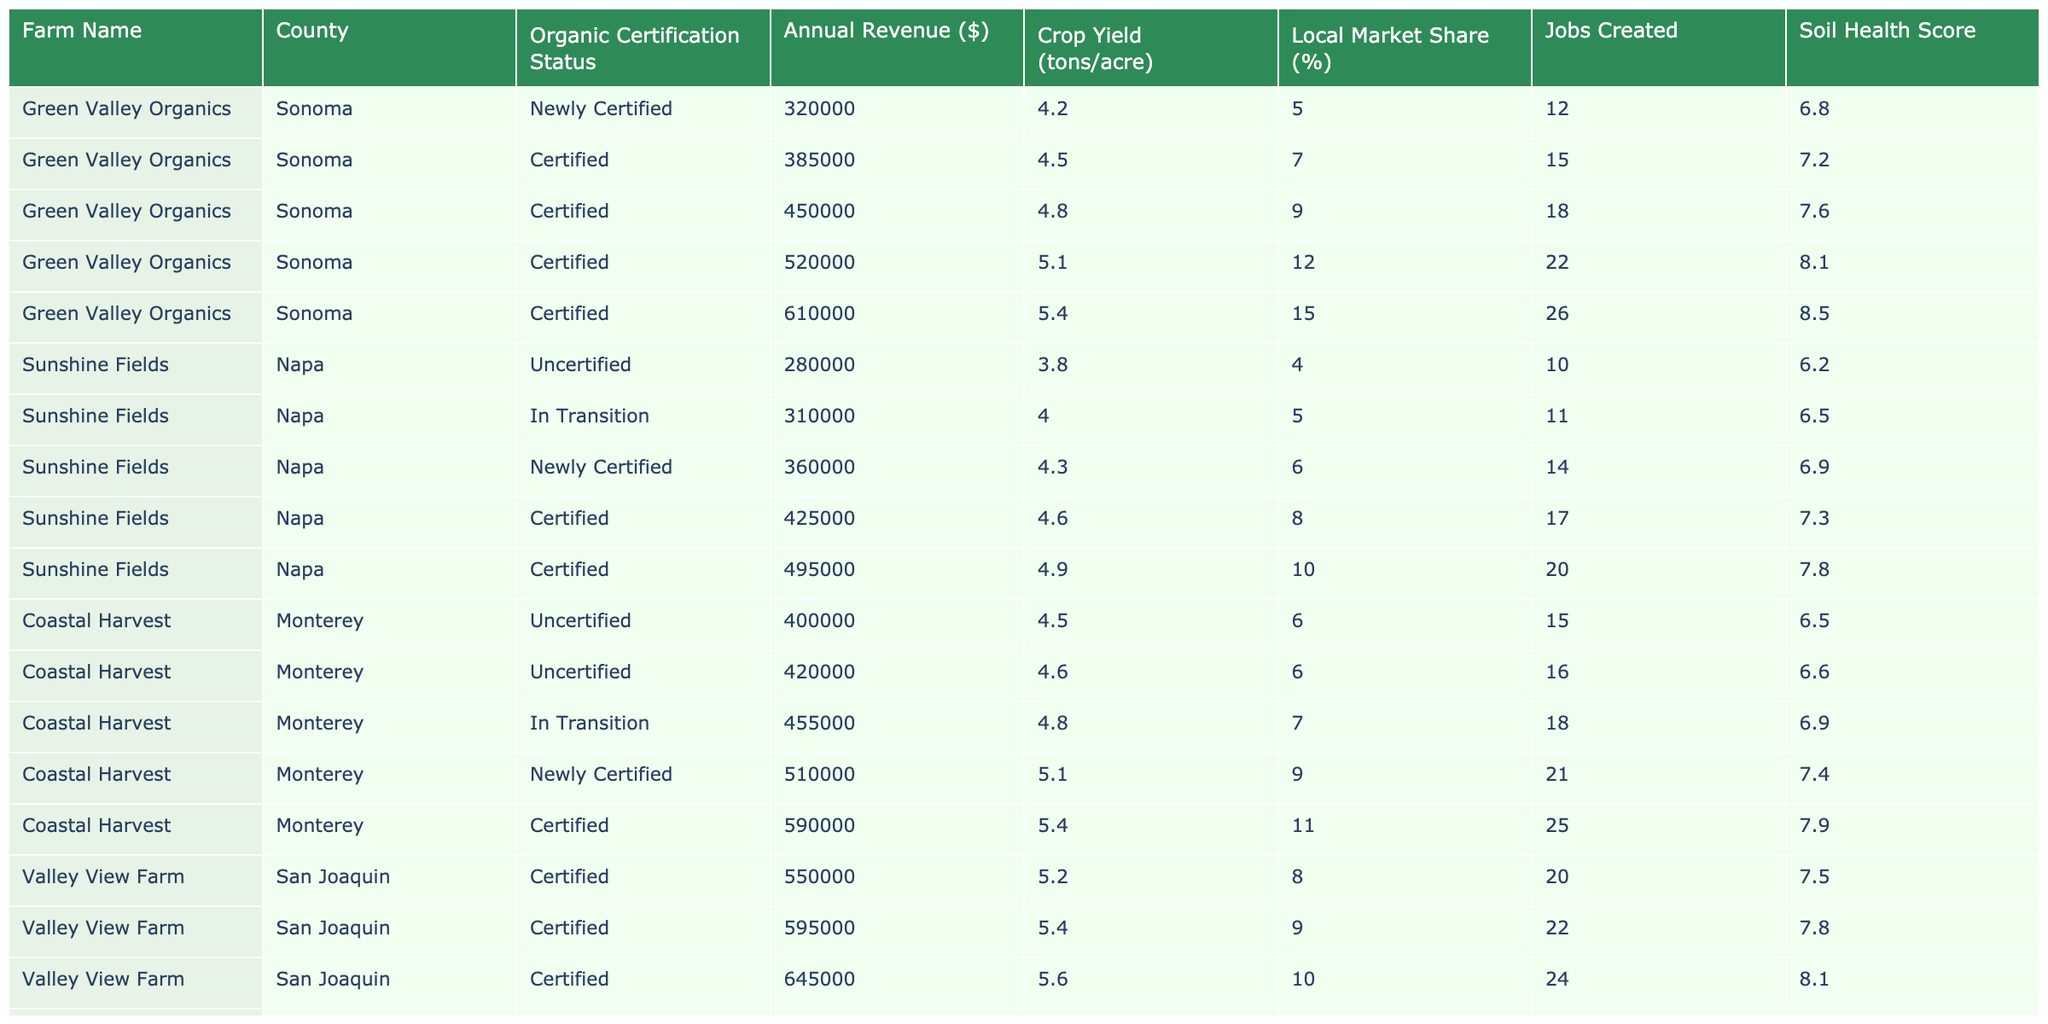What was the annual revenue of Green Valley Organics in 2022? Referring to the table, the annual revenue of Green Valley Organics in the year 2022 is specifically indicated as $610,000.
Answer: $610,000 How many jobs did Valley View Farm create in 2021? The table shows that Valley View Farm created 27 jobs in the year 2021.
Answer: 27 What is the percentage increase in annual revenue for Sunshine Fields from 2018 to 2022? The annual revenue for Sunshine Fields in 2018 was $280,000 and in 2022 it was $495,000. The increase is $495,000 - $280,000 = $215,000. To find the percentage increase, divide the increase by the original value and multiply by 100: ($215,000 / $280,000) * 100 = 76.79%.
Answer: 76.79% Did Coastal Harvest have a higher soil health score in 2022 compared to its score in 2018? In 2018, Coastal Harvest had a soil health score of 6.5, and in 2022 it had a score of 7.9. Since 7.9 is greater than 6.5, the statement is true.
Answer: Yes What was the average crop yield for Green Valley Organics over the 5-year period? The crop yields from 2018 to 2022 for Green Valley Organics are 4.2, 4.5, 4.8, 5.1, and 5.4 tons/acre. Adding these gives a sum of 24.0. Dividing by 5 yields an average crop yield of 24.0 / 5 = 4.8 tons/acre.
Answer: 4.8 tons/acre Which farm created the most jobs in 2022, and how many jobs did it create? Referring to the table, Green Valley Organics created 26 jobs in 2022, while Sunshine Fields created 20 and Coastal Harvest created 25 jobs. Thus, Green Valley Organics created the most jobs at 26.
Answer: Green Valley Organics, 26 jobs What was the local market share percentage increase for Valley View Farm from 2018 to 2022? Valley View Farm's local market share percentage in 2018 was 8%, and in 2022 it was 14%. The increase is 14% - 8% = 6%.
Answer: 6% Was the annual revenue of Coastal Harvest higher in 2021 than in 2020? The table indicates that Coastal Harvest had an annual revenue of $510,000 in 2021 compared to $455,000 in 2020. Since $510,000 is more than $455,000, the statement is true.
Answer: Yes What is the soil health score difference between the newly certified status in 2020 and the certified status in 2022 for Sunshine Fields? Sunshine Fields had a soil health score of 6.9 when newly certified in 2020 and a score of 7.8 when certified in 2022. The difference is 7.8 - 6.9 = 0.9.
Answer: 0.9 Which farm had the highest annual revenue in 2021, and what was that revenue? In 2021, Valley View Farm had the highest annual revenue of $700,000 compared to Green Valley Organics' $520,000, Sunshine Fields' $425,000, and Coastal Harvest's $510,000.
Answer: Valley View Farm, $700,000 